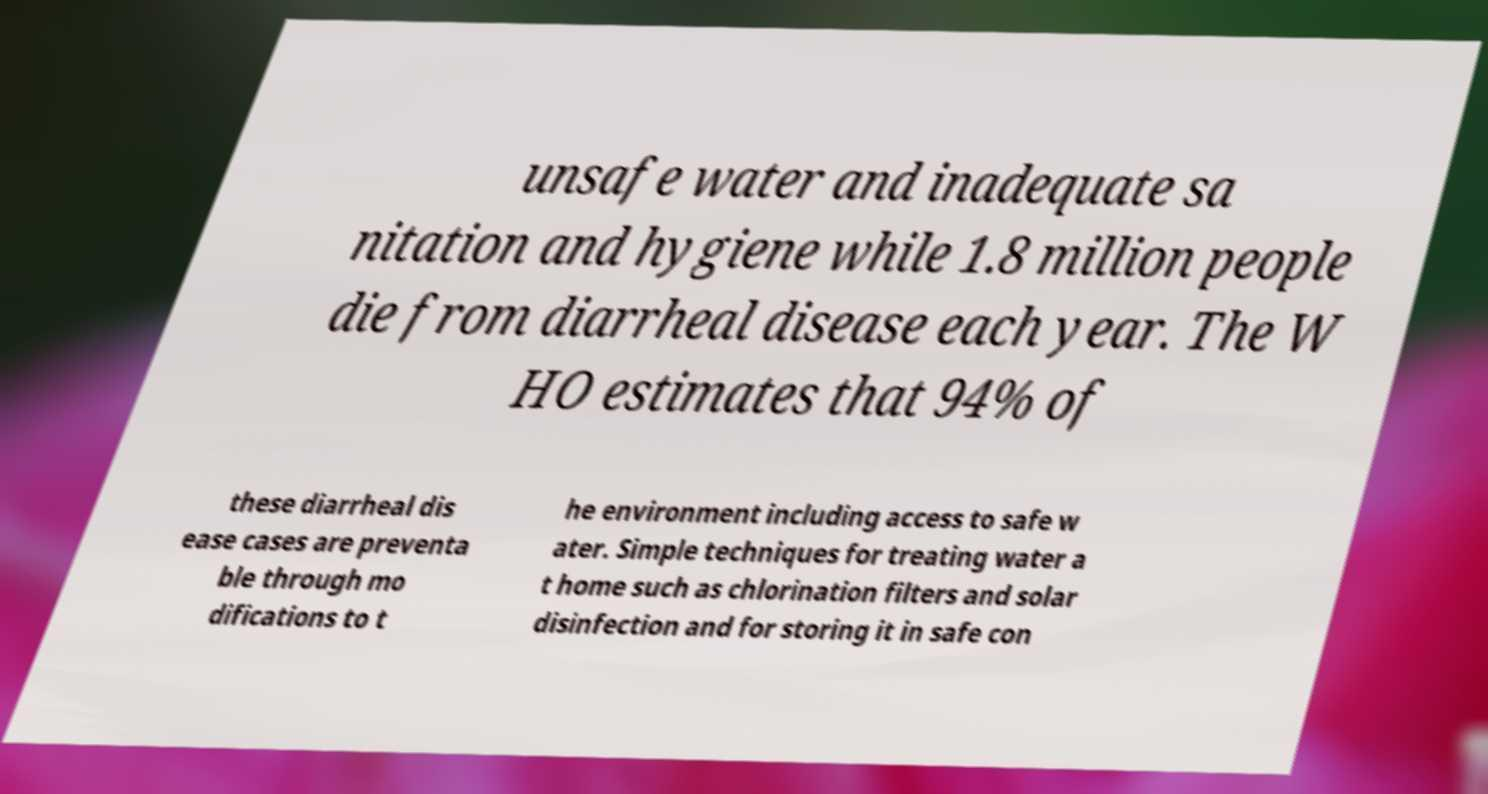Could you assist in decoding the text presented in this image and type it out clearly? unsafe water and inadequate sa nitation and hygiene while 1.8 million people die from diarrheal disease each year. The W HO estimates that 94% of these diarrheal dis ease cases are preventa ble through mo difications to t he environment including access to safe w ater. Simple techniques for treating water a t home such as chlorination filters and solar disinfection and for storing it in safe con 